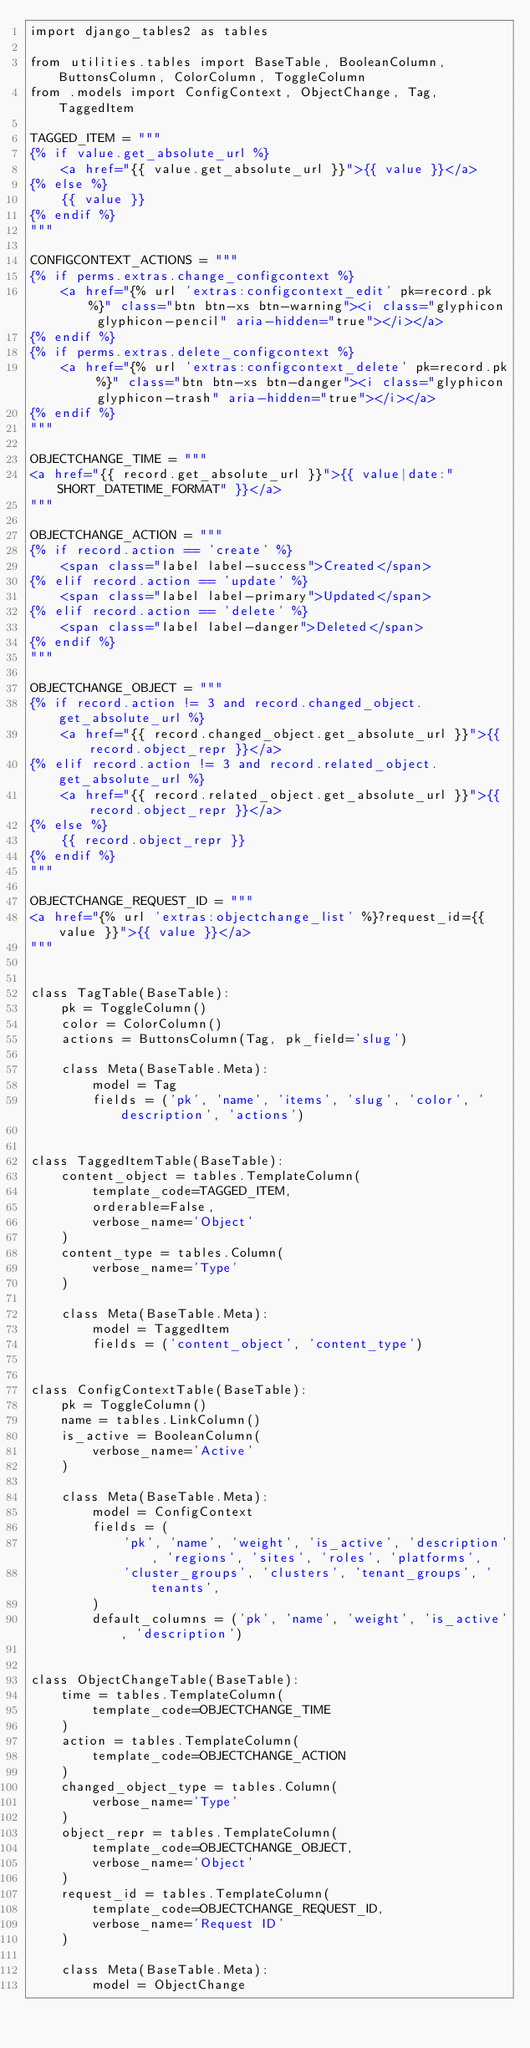<code> <loc_0><loc_0><loc_500><loc_500><_Python_>import django_tables2 as tables

from utilities.tables import BaseTable, BooleanColumn, ButtonsColumn, ColorColumn, ToggleColumn
from .models import ConfigContext, ObjectChange, Tag, TaggedItem

TAGGED_ITEM = """
{% if value.get_absolute_url %}
    <a href="{{ value.get_absolute_url }}">{{ value }}</a>
{% else %}
    {{ value }}
{% endif %}
"""

CONFIGCONTEXT_ACTIONS = """
{% if perms.extras.change_configcontext %}
    <a href="{% url 'extras:configcontext_edit' pk=record.pk %}" class="btn btn-xs btn-warning"><i class="glyphicon glyphicon-pencil" aria-hidden="true"></i></a>
{% endif %}
{% if perms.extras.delete_configcontext %}
    <a href="{% url 'extras:configcontext_delete' pk=record.pk %}" class="btn btn-xs btn-danger"><i class="glyphicon glyphicon-trash" aria-hidden="true"></i></a>
{% endif %}
"""

OBJECTCHANGE_TIME = """
<a href="{{ record.get_absolute_url }}">{{ value|date:"SHORT_DATETIME_FORMAT" }}</a>
"""

OBJECTCHANGE_ACTION = """
{% if record.action == 'create' %}
    <span class="label label-success">Created</span>
{% elif record.action == 'update' %}
    <span class="label label-primary">Updated</span>
{% elif record.action == 'delete' %}
    <span class="label label-danger">Deleted</span>
{% endif %}
"""

OBJECTCHANGE_OBJECT = """
{% if record.action != 3 and record.changed_object.get_absolute_url %}
    <a href="{{ record.changed_object.get_absolute_url }}">{{ record.object_repr }}</a>
{% elif record.action != 3 and record.related_object.get_absolute_url %}
    <a href="{{ record.related_object.get_absolute_url }}">{{ record.object_repr }}</a>
{% else %}
    {{ record.object_repr }}
{% endif %}
"""

OBJECTCHANGE_REQUEST_ID = """
<a href="{% url 'extras:objectchange_list' %}?request_id={{ value }}">{{ value }}</a>
"""


class TagTable(BaseTable):
    pk = ToggleColumn()
    color = ColorColumn()
    actions = ButtonsColumn(Tag, pk_field='slug')

    class Meta(BaseTable.Meta):
        model = Tag
        fields = ('pk', 'name', 'items', 'slug', 'color', 'description', 'actions')


class TaggedItemTable(BaseTable):
    content_object = tables.TemplateColumn(
        template_code=TAGGED_ITEM,
        orderable=False,
        verbose_name='Object'
    )
    content_type = tables.Column(
        verbose_name='Type'
    )

    class Meta(BaseTable.Meta):
        model = TaggedItem
        fields = ('content_object', 'content_type')


class ConfigContextTable(BaseTable):
    pk = ToggleColumn()
    name = tables.LinkColumn()
    is_active = BooleanColumn(
        verbose_name='Active'
    )

    class Meta(BaseTable.Meta):
        model = ConfigContext
        fields = (
            'pk', 'name', 'weight', 'is_active', 'description', 'regions', 'sites', 'roles', 'platforms',
            'cluster_groups', 'clusters', 'tenant_groups', 'tenants',
        )
        default_columns = ('pk', 'name', 'weight', 'is_active', 'description')


class ObjectChangeTable(BaseTable):
    time = tables.TemplateColumn(
        template_code=OBJECTCHANGE_TIME
    )
    action = tables.TemplateColumn(
        template_code=OBJECTCHANGE_ACTION
    )
    changed_object_type = tables.Column(
        verbose_name='Type'
    )
    object_repr = tables.TemplateColumn(
        template_code=OBJECTCHANGE_OBJECT,
        verbose_name='Object'
    )
    request_id = tables.TemplateColumn(
        template_code=OBJECTCHANGE_REQUEST_ID,
        verbose_name='Request ID'
    )

    class Meta(BaseTable.Meta):
        model = ObjectChange</code> 